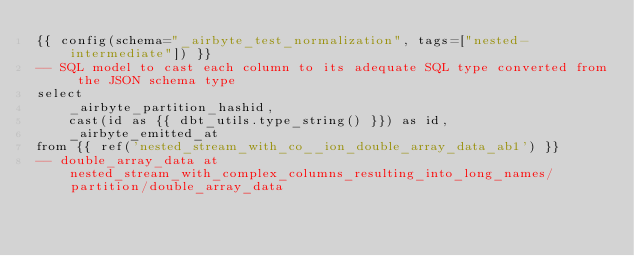<code> <loc_0><loc_0><loc_500><loc_500><_SQL_>{{ config(schema="_airbyte_test_normalization", tags=["nested-intermediate"]) }}
-- SQL model to cast each column to its adequate SQL type converted from the JSON schema type
select
    _airbyte_partition_hashid,
    cast(id as {{ dbt_utils.type_string() }}) as id,
    _airbyte_emitted_at
from {{ ref('nested_stream_with_co__ion_double_array_data_ab1') }}
-- double_array_data at nested_stream_with_complex_columns_resulting_into_long_names/partition/double_array_data

</code> 